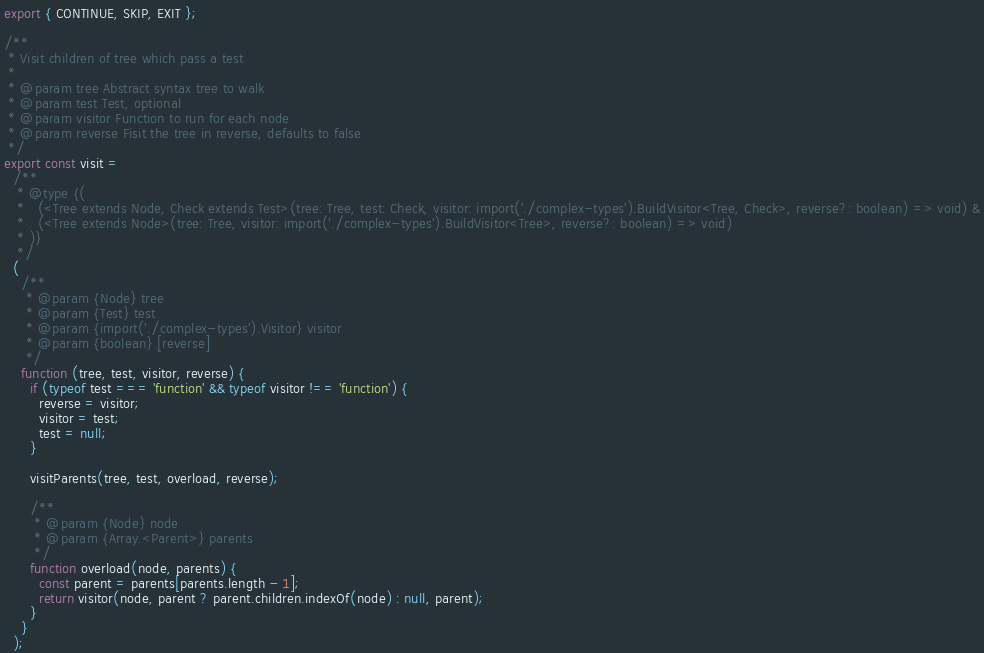<code> <loc_0><loc_0><loc_500><loc_500><_JavaScript_>
export { CONTINUE, SKIP, EXIT };

/**
 * Visit children of tree which pass a test
 *
 * @param tree Abstract syntax tree to walk
 * @param test Test, optional
 * @param visitor Function to run for each node
 * @param reverse Fisit the tree in reverse, defaults to false
 */
export const visit =
  /**
   * @type {(
   *   (<Tree extends Node, Check extends Test>(tree: Tree, test: Check, visitor: import('./complex-types').BuildVisitor<Tree, Check>, reverse?: boolean) => void) &
   *   (<Tree extends Node>(tree: Tree, visitor: import('./complex-types').BuildVisitor<Tree>, reverse?: boolean) => void)
   * )}
   */
  (
    /**
     * @param {Node} tree
     * @param {Test} test
     * @param {import('./complex-types').Visitor} visitor
     * @param {boolean} [reverse]
     */
    function (tree, test, visitor, reverse) {
      if (typeof test === 'function' && typeof visitor !== 'function') {
        reverse = visitor;
        visitor = test;
        test = null;
      }

      visitParents(tree, test, overload, reverse);

      /**
       * @param {Node} node
       * @param {Array.<Parent>} parents
       */
      function overload(node, parents) {
        const parent = parents[parents.length - 1];
        return visitor(node, parent ? parent.children.indexOf(node) : null, parent);
      }
    }
  );
</code> 